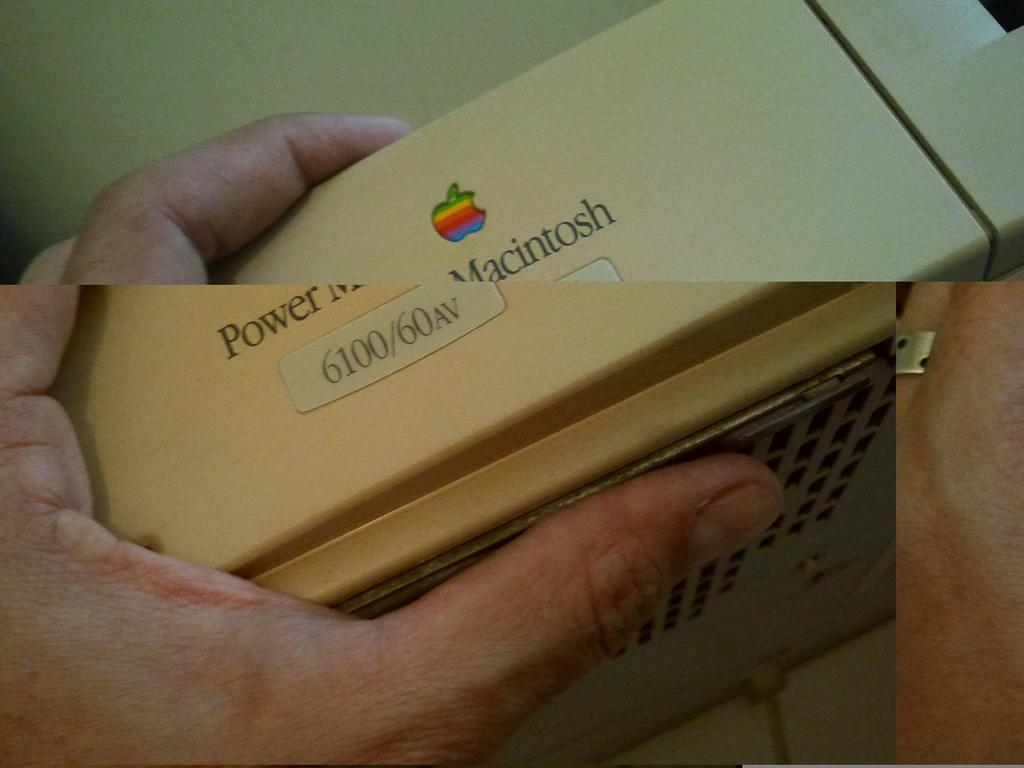<image>
Relay a brief, clear account of the picture shown. A Macintosh logo can be seen on a device in a person's hand. 